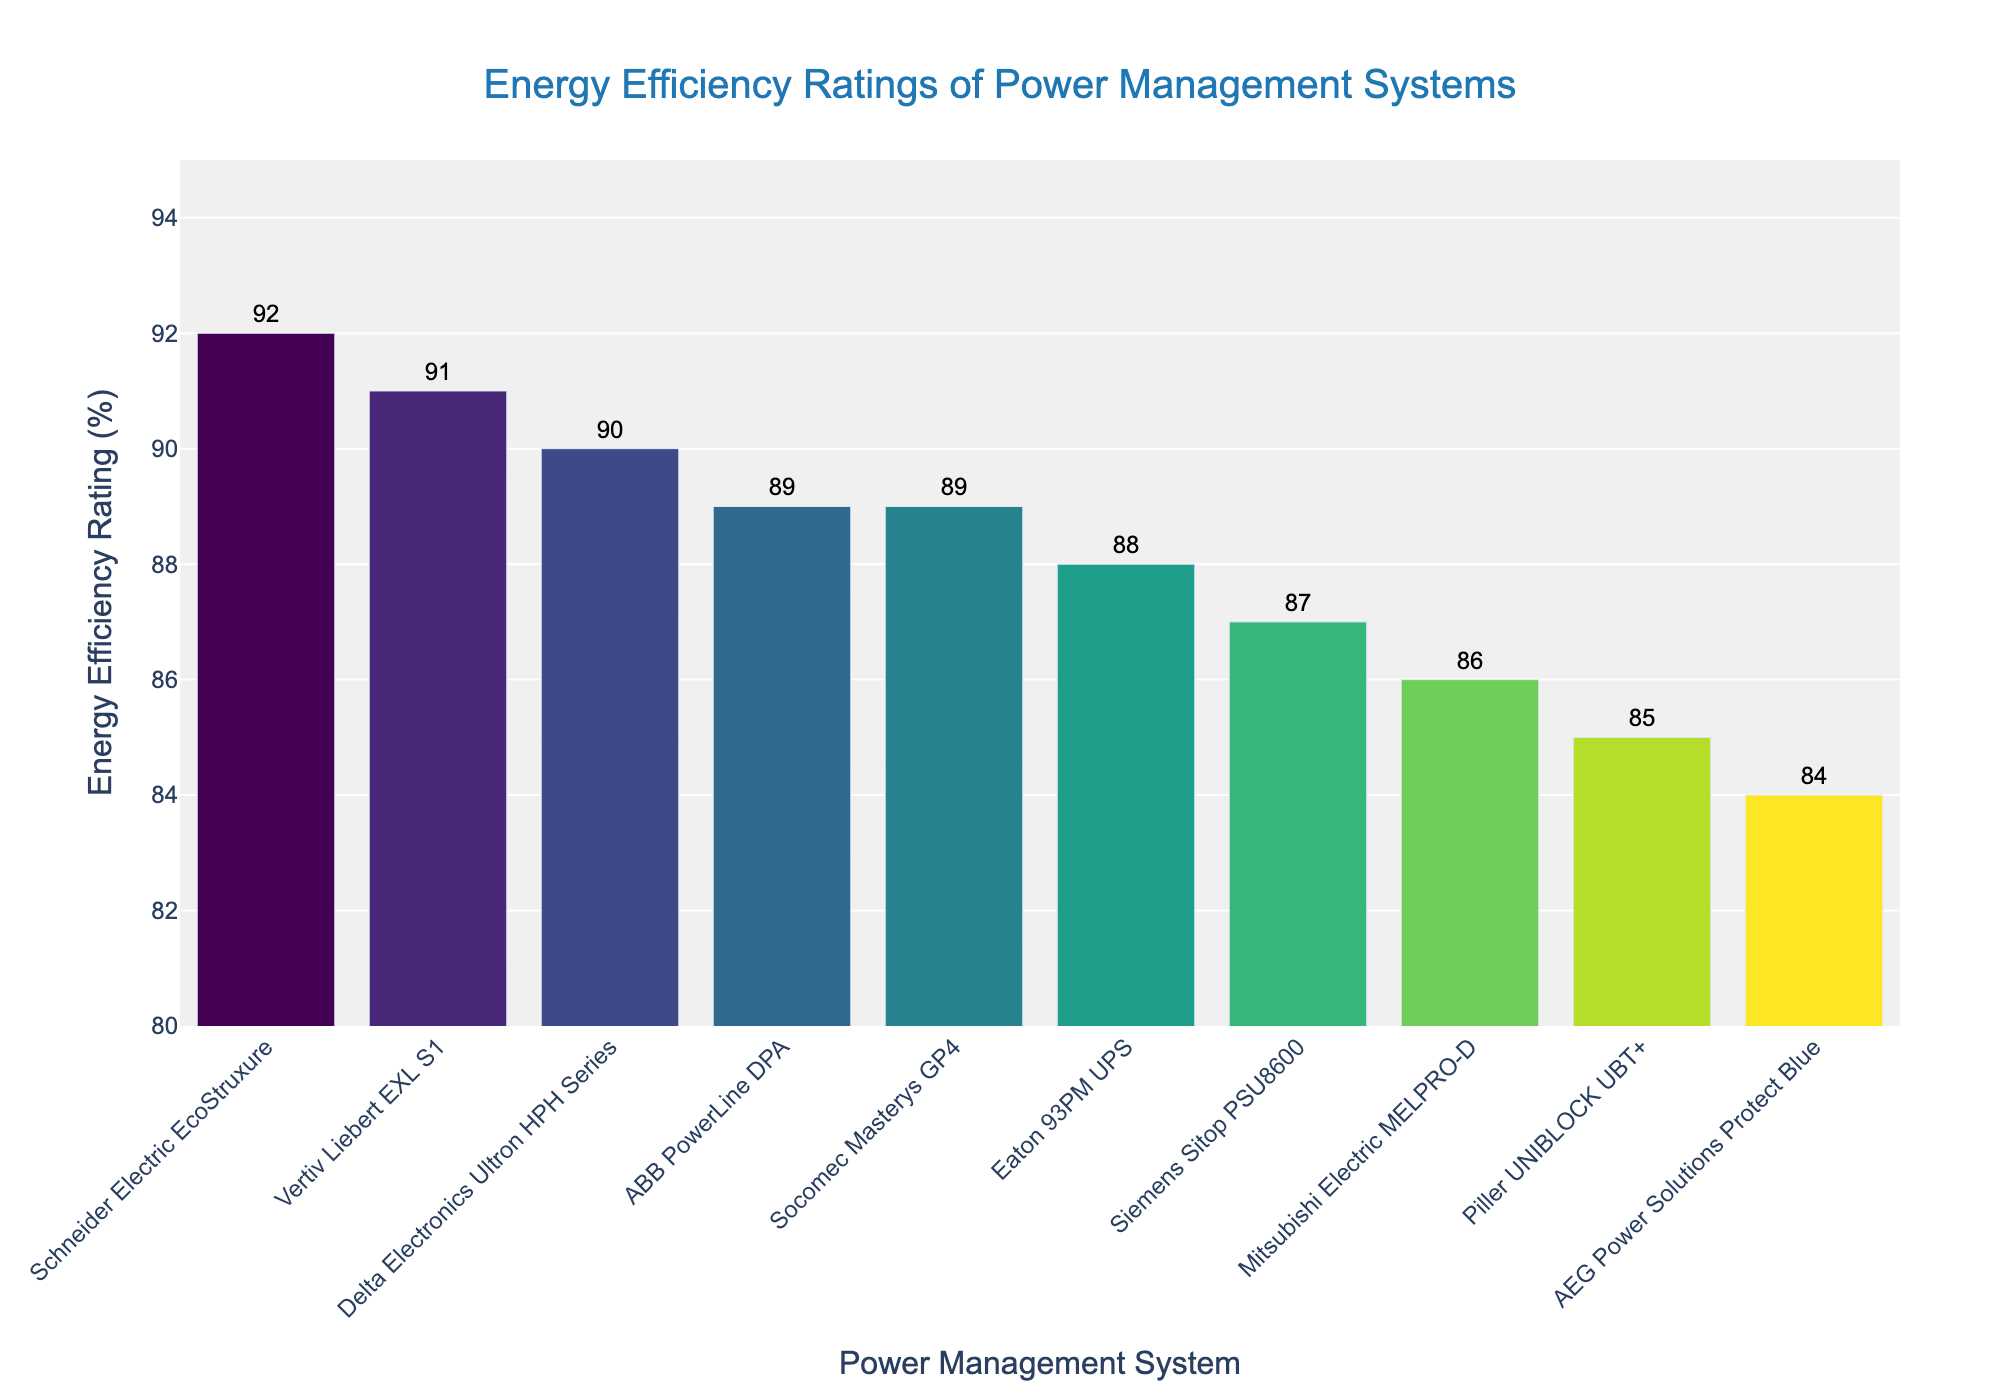Which power management system has the highest energy efficiency rating? The figure sorts the systems by their energy efficiency ratings in descending order. The highest bar corresponds to the Schneider Electric EcoStruxure system with a rating of 92%.
Answer: Schneider Electric EcoStruxure Which two systems have identical energy efficiency ratings? In the figure, the bars for ABB PowerLine DPA and Socomec Masterys GP4 are at the same height, both showing an energy efficiency rating of 89%.
Answer: ABB PowerLine DPA and Socomec Masterys GP4 How much higher is the energy efficiency rating of the Schneider Electric EcoStruxure compared to the Piller UNIBLOCK UBT+? The energy efficiency rating for the Schneider Electric EcoStruxure is 92%, while for the Piller UNIBLOCK UBT+ it is 85%. The difference is calculated as 92% - 85% = 7%.
Answer: 7% What is the average energy efficiency rating of the top three power management systems? The top three systems are Schneider Electric EcoStruxure (92%), Vertiv Liebert EXL S1 (91%), and Delta Electronics Ultron HPH Series (90%). The average is calculated as (92 + 91 + 90) / 3 = 91%.
Answer: 91% Which system has the lowest energy efficiency rating and what is its value? The shortest bar in the figure represents the AEG Power Solutions Protect Blue system, which has an energy efficiency rating of 84%.
Answer: AEG Power Solutions Protect Blue, 84% Are there more systems with energy efficiency ratings above or below 90%? From the figure, we see that 3 systems are above 90% (Schneider Electric EcoStruxure, Vertiv Liebert EXL S1, Delta Electronics Ultron HPH Series) and 7 systems are below 90%.
Answer: Below 90% How many systems have an energy efficiency rating below the average of 89%? To find the number of systems below the average rating of 89%, count the bars below this threshold: Siemens Sitop PSU8600, Mitsubishi Electric MELPRO-D, Piller UNIBLOCK UBT+, and AEG Power Solutions Protect Blue. There are 4 such systems.
Answer: 4 If the energy efficiency ratings for Mitsubishi Electric MELPRO-D and Delta Electronics Ultron HPH Series were swapped, which system would then have the highest rating below 90%? Swapping ratings makes Delta Electronics Ultron HPH Series = 86% and Mitsubishi Electric MELPRO-D = 90%. This means ABB PowerLine DPA and Socomec Masterys GP4 (both 89%) would then have the highest ratings below 90%.
Answer: ABB PowerLine DPA and Socomec Masterys GP4 What is the median energy efficiency rating of all the power management systems? To find the median rating, list the ratings in numerical order: 84, 85, 86, 87, 88, 89, 89, 90, 91, 92. The median is the average of the 5th and 6th values in this sorted list: (88 + 89) / 2 = 88.5%.
Answer: 88.5% 